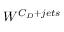<formula> <loc_0><loc_0><loc_500><loc_500>W ^ { C _ { D } + j e t s }</formula> 